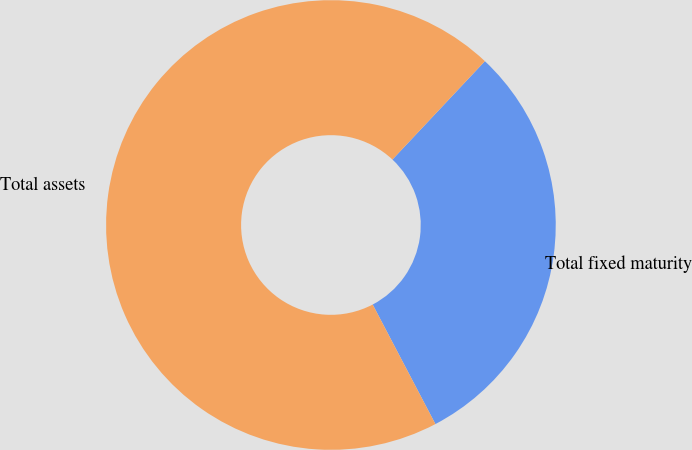Convert chart to OTSL. <chart><loc_0><loc_0><loc_500><loc_500><pie_chart><fcel>Total fixed maturity<fcel>Total assets<nl><fcel>30.3%<fcel>69.7%<nl></chart> 